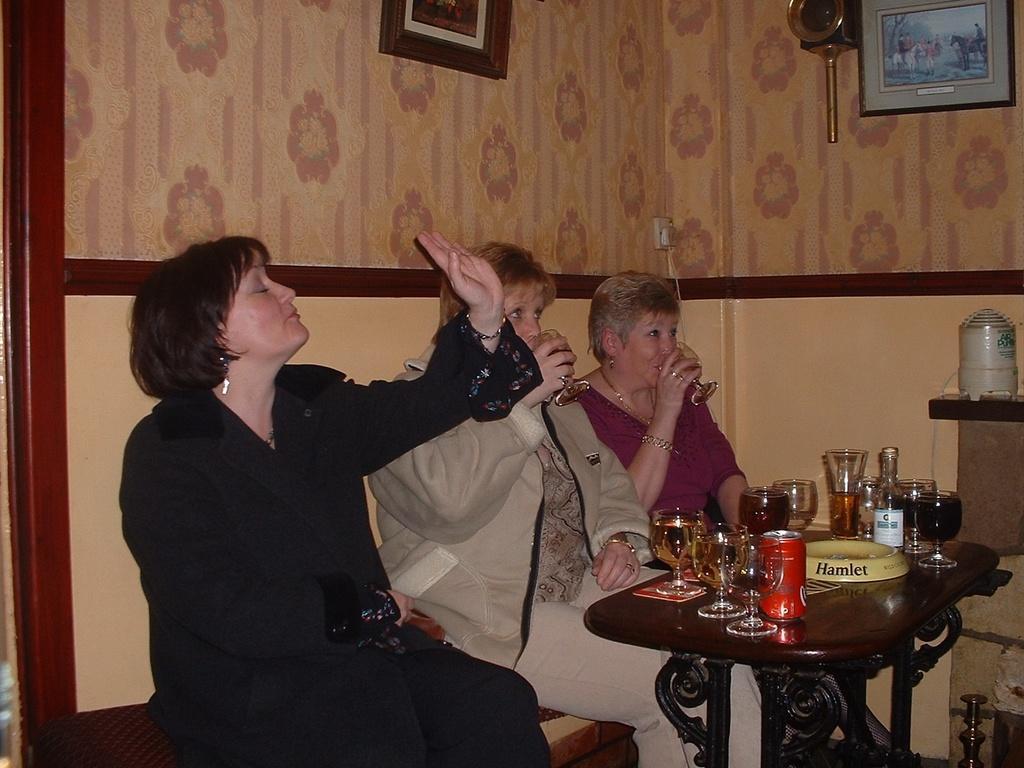Could you give a brief overview of what you see in this image? There are three woman sitting in the chairs in front of a table on which some glasses, coke tins were placed. Two of the women were drinking. In the background there are some photo frames attached to the wall. 